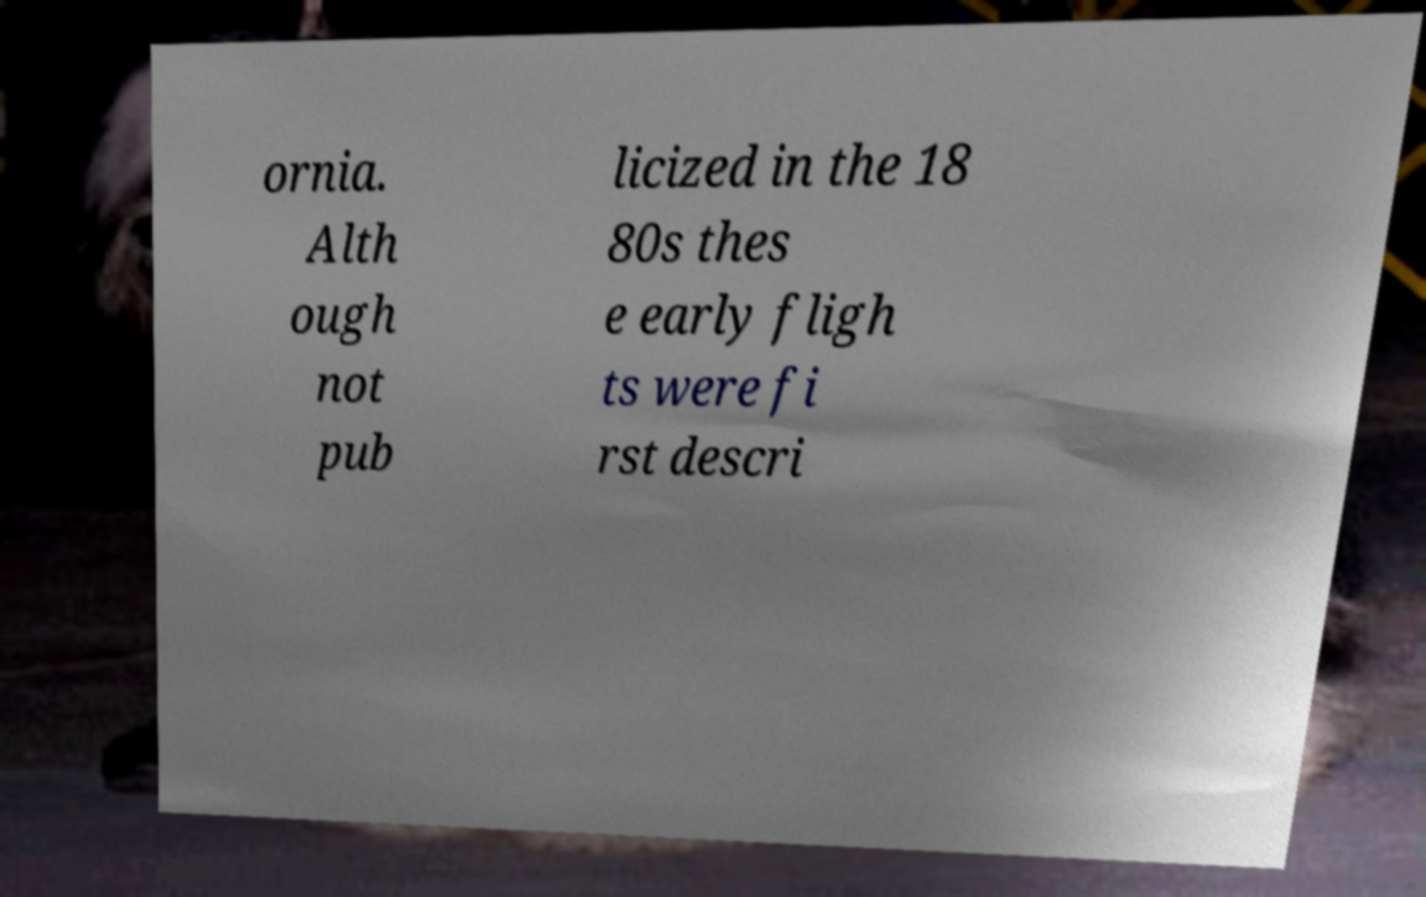For documentation purposes, I need the text within this image transcribed. Could you provide that? ornia. Alth ough not pub licized in the 18 80s thes e early fligh ts were fi rst descri 